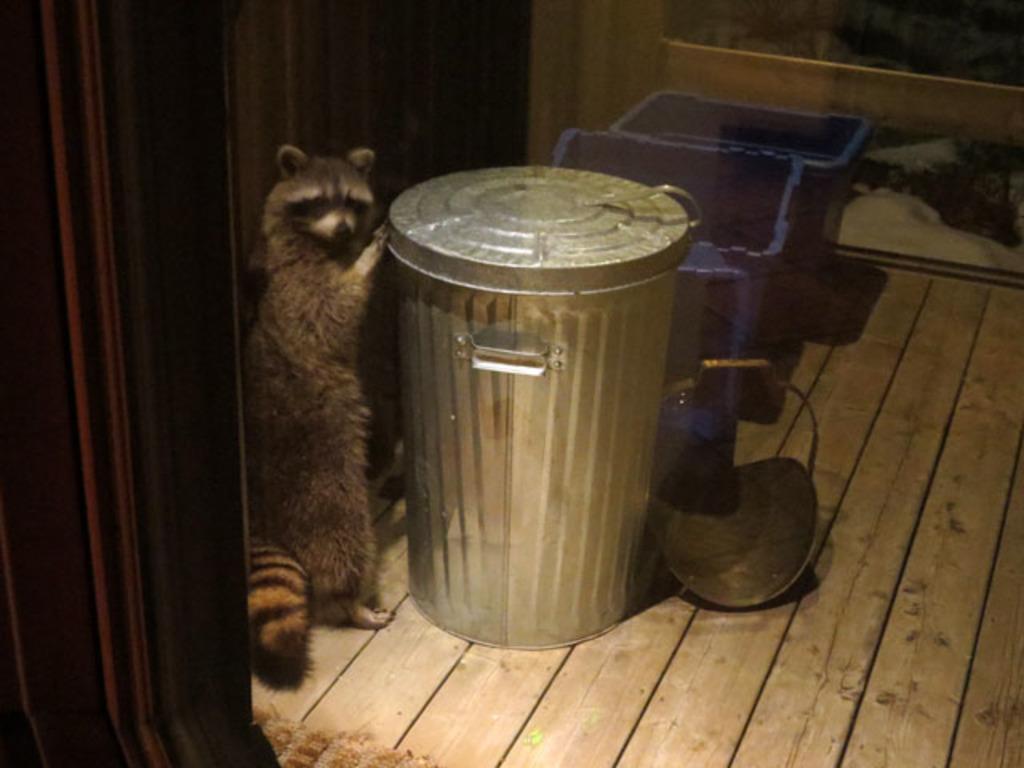Please provide a concise description of this image. In this image we can see an animal standing on the floor and holding the bin. 